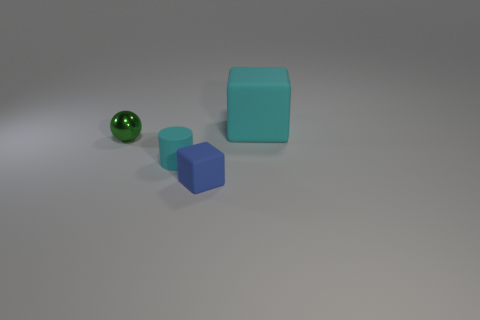Are there any other things that are the same shape as the small green object?
Keep it short and to the point. No. Are there any other things that are the same material as the green object?
Offer a terse response. No. The blue object has what size?
Your response must be concise. Small. What color is the tiny object that is in front of the small green sphere and left of the tiny cube?
Offer a terse response. Cyan. Is the number of tiny metallic objects greater than the number of blocks?
Ensure brevity in your answer.  No. How many objects are either matte things or cyan things behind the cyan cylinder?
Make the answer very short. 3. Does the metallic thing have the same size as the blue matte object?
Offer a terse response. Yes. Are there any tiny blue objects in front of the big cyan thing?
Offer a very short reply. Yes. There is a object that is on the left side of the blue rubber thing and behind the small cyan thing; how big is it?
Provide a short and direct response. Small. How many things are either matte cubes or large green cylinders?
Ensure brevity in your answer.  2. 